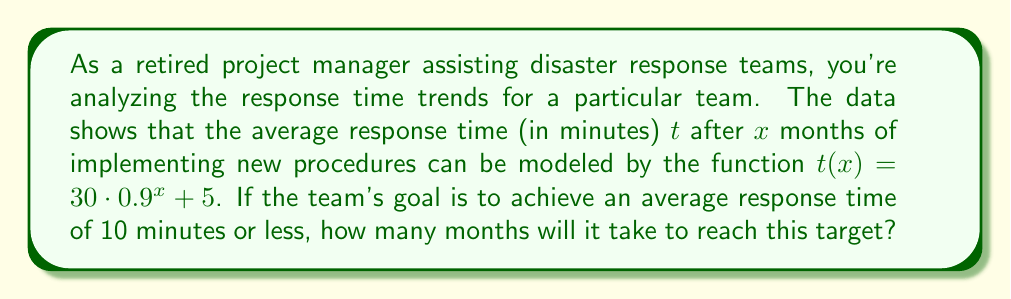What is the answer to this math problem? To solve this problem, we need to use the given exponential regression model and solve for $x$ when $t(x) = 10$. Let's approach this step-by-step:

1) The model is given by: $t(x) = 30 \cdot 0.9^x + 5$

2) We want to find $x$ when $t(x) = 10$, so we set up the equation:
   $$10 = 30 \cdot 0.9^x + 5$$

3) Subtract 5 from both sides:
   $$5 = 30 \cdot 0.9^x$$

4) Divide both sides by 30:
   $$\frac{1}{6} = 0.9^x$$

5) Take the natural logarithm of both sides:
   $$\ln(\frac{1}{6}) = \ln(0.9^x)$$

6) Use the logarithm property $\ln(a^b) = b\ln(a)$:
   $$\ln(\frac{1}{6}) = x\ln(0.9)$$

7) Solve for $x$:
   $$x = \frac{\ln(\frac{1}{6})}{\ln(0.9)}$$

8) Calculate the value (you can use a calculator for this):
   $$x \approx 16.58$$

9) Since we can't have a fractional month in this context, we need to round up to the nearest whole month.
Answer: It will take 17 months to reach the target average response time of 10 minutes or less. 